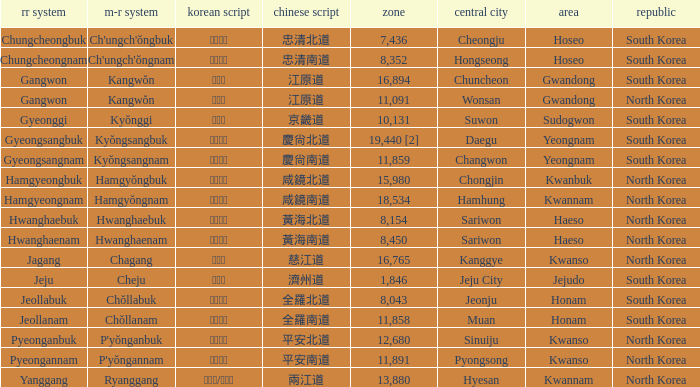What is the RR Romaja for the province that has Hangul of 강원도 and capital of Wonsan? Gangwon. Write the full table. {'header': ['rr system', 'm-r system', 'korean script', 'chinese script', 'zone', 'central city', 'area', 'republic'], 'rows': [['Chungcheongbuk', "Ch'ungch'ŏngbuk", '충청북도', '忠清北道', '7,436', 'Cheongju', 'Hoseo', 'South Korea'], ['Chungcheongnam', "Ch'ungch'ŏngnam", '충청남도', '忠清南道', '8,352', 'Hongseong', 'Hoseo', 'South Korea'], ['Gangwon', 'Kangwŏn', '강원도', '江原道', '16,894', 'Chuncheon', 'Gwandong', 'South Korea'], ['Gangwon', 'Kangwŏn', '강원도', '江原道', '11,091', 'Wonsan', 'Gwandong', 'North Korea'], ['Gyeonggi', 'Kyŏnggi', '경기도', '京畿道', '10,131', 'Suwon', 'Sudogwon', 'South Korea'], ['Gyeongsangbuk', 'Kyŏngsangbuk', '경상북도', '慶尙北道', '19,440 [2]', 'Daegu', 'Yeongnam', 'South Korea'], ['Gyeongsangnam', 'Kyŏngsangnam', '경상남도', '慶尙南道', '11,859', 'Changwon', 'Yeongnam', 'South Korea'], ['Hamgyeongbuk', 'Hamgyŏngbuk', '함경북도', '咸鏡北道', '15,980', 'Chongjin', 'Kwanbuk', 'North Korea'], ['Hamgyeongnam', 'Hamgyŏngnam', '함경남도', '咸鏡南道', '18,534', 'Hamhung', 'Kwannam', 'North Korea'], ['Hwanghaebuk', 'Hwanghaebuk', '황해북도', '黃海北道', '8,154', 'Sariwon', 'Haeso', 'North Korea'], ['Hwanghaenam', 'Hwanghaenam', '황해남도', '黃海南道', '8,450', 'Sariwon', 'Haeso', 'North Korea'], ['Jagang', 'Chagang', '자강도', '慈江道', '16,765', 'Kanggye', 'Kwanso', 'North Korea'], ['Jeju', 'Cheju', '제주도', '濟州道', '1,846', 'Jeju City', 'Jejudo', 'South Korea'], ['Jeollabuk', 'Chŏllabuk', '전라북도', '全羅北道', '8,043', 'Jeonju', 'Honam', 'South Korea'], ['Jeollanam', 'Chŏllanam', '전라남도', '全羅南道', '11,858', 'Muan', 'Honam', 'South Korea'], ['Pyeonganbuk', "P'yŏnganbuk", '평안북도', '平安北道', '12,680', 'Sinuiju', 'Kwanso', 'North Korea'], ['Pyeongannam', "P'yŏngannam", '평안남도', '平安南道', '11,891', 'Pyongsong', 'Kwanso', 'North Korea'], ['Yanggang', 'Ryanggang', '량강도/양강도', '兩江道', '13,880', 'Hyesan', 'Kwannam', 'North Korea']]} 